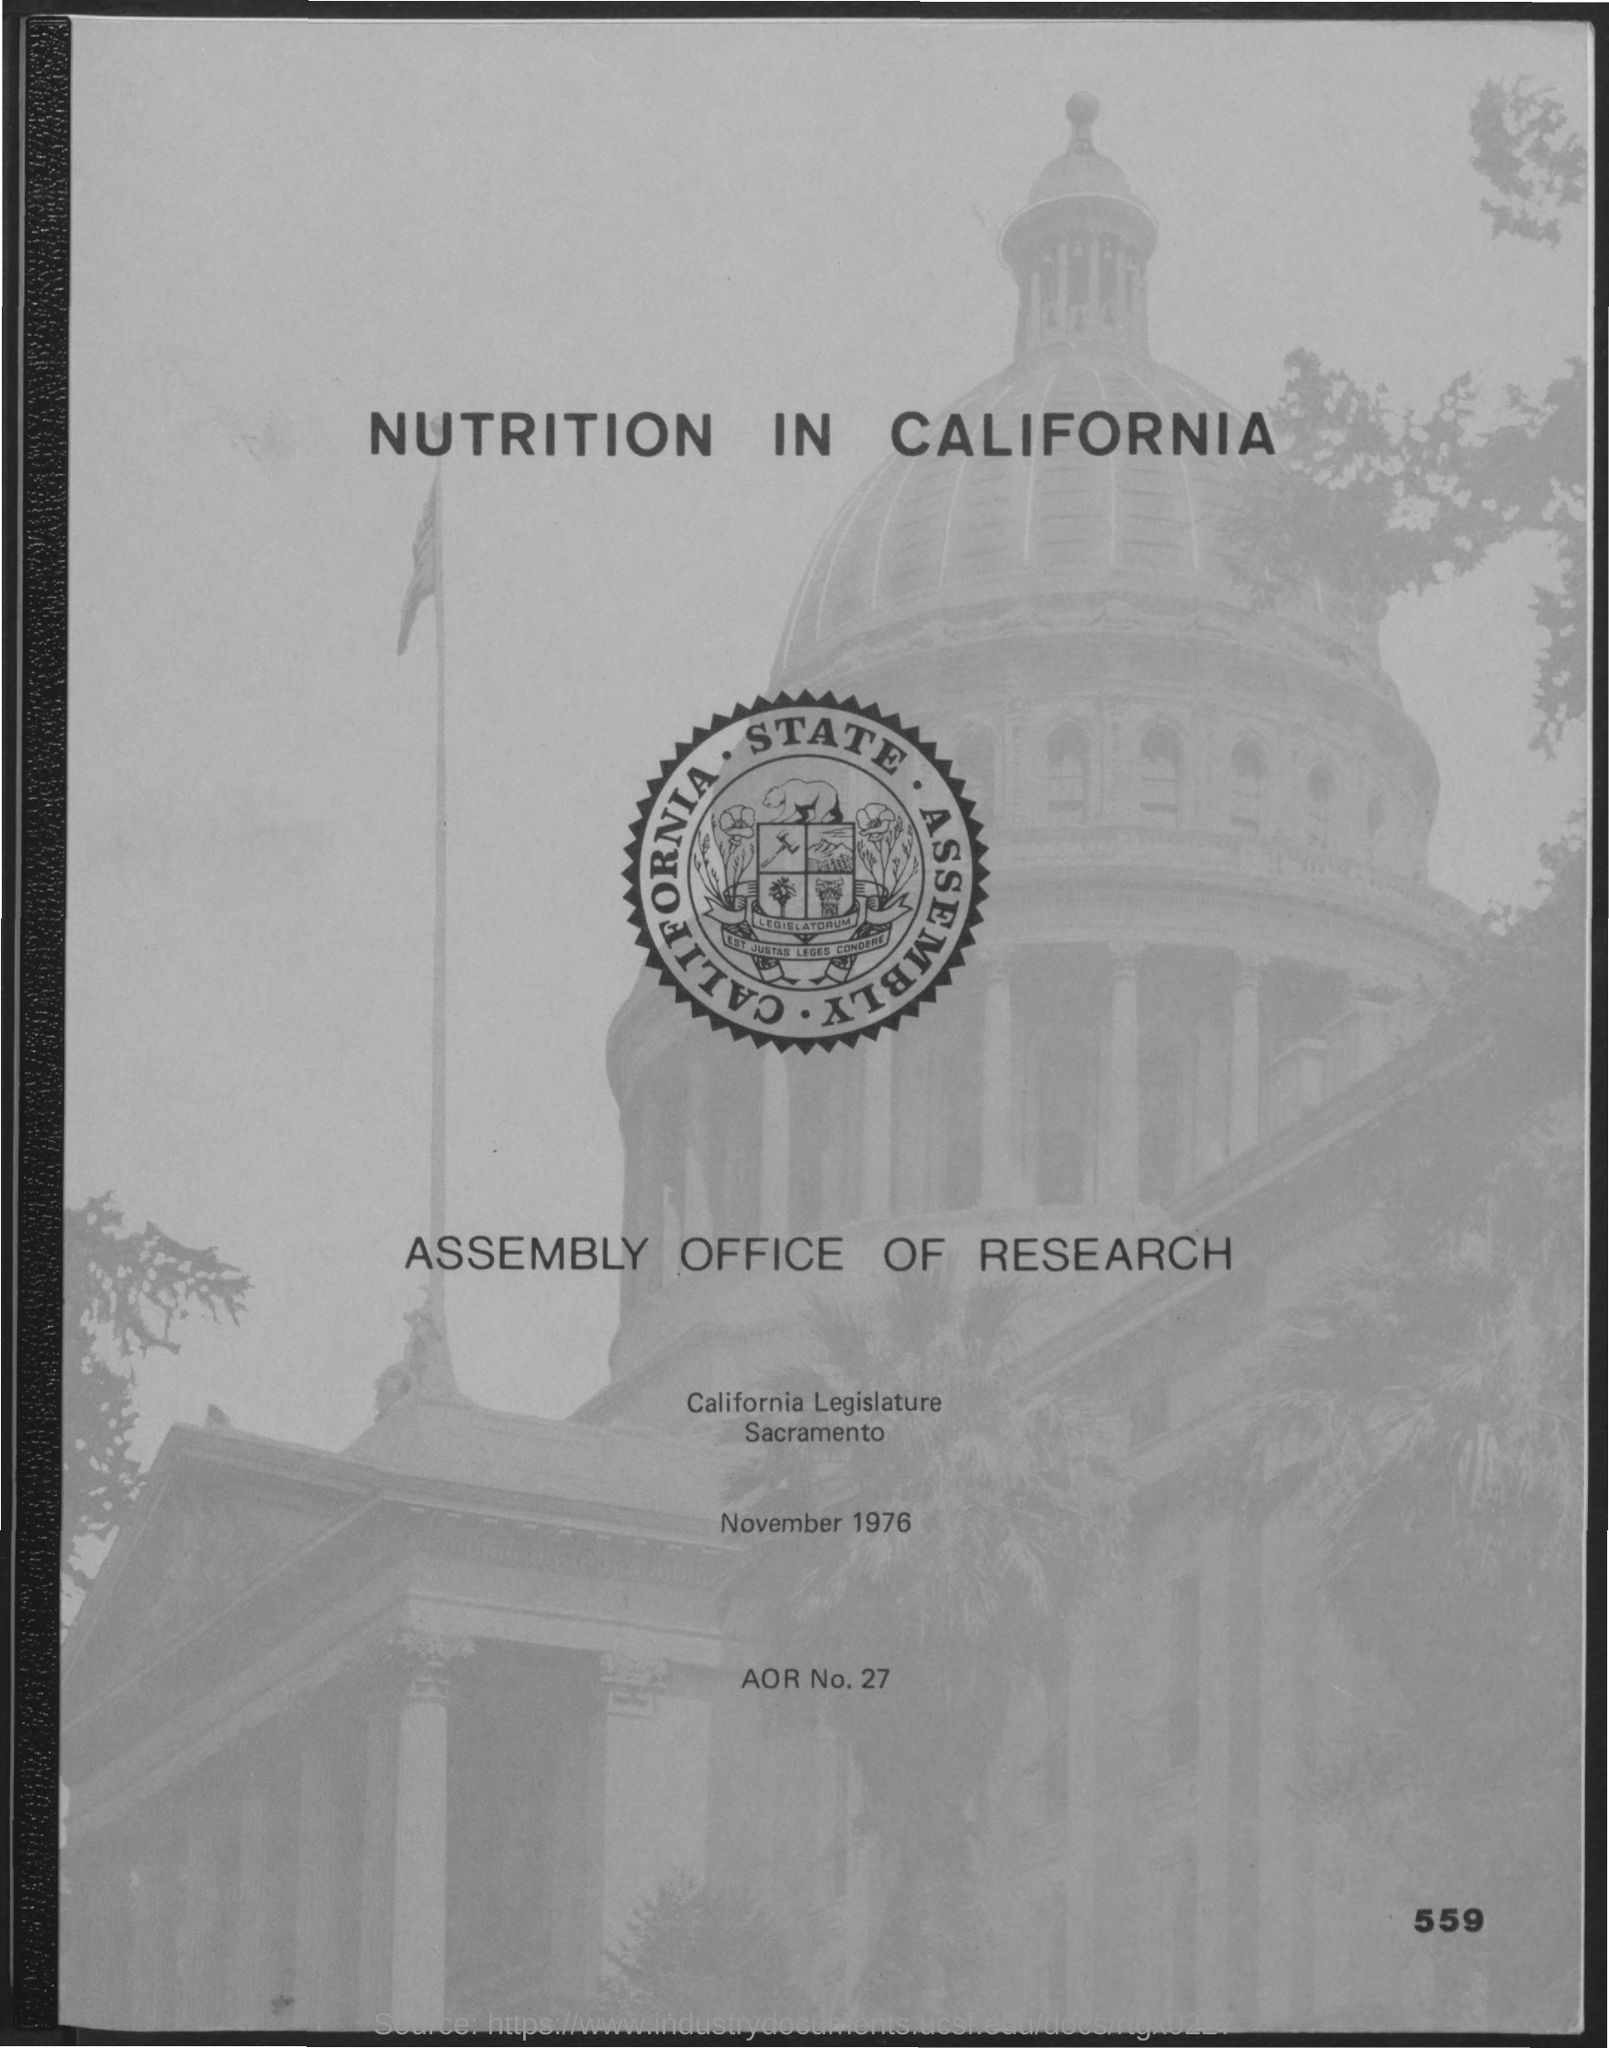What is the date mentioned in the given page ?
Make the answer very short. November 1976. What is the aor no. mentioned in the given page ?
Provide a short and direct response. 27. 